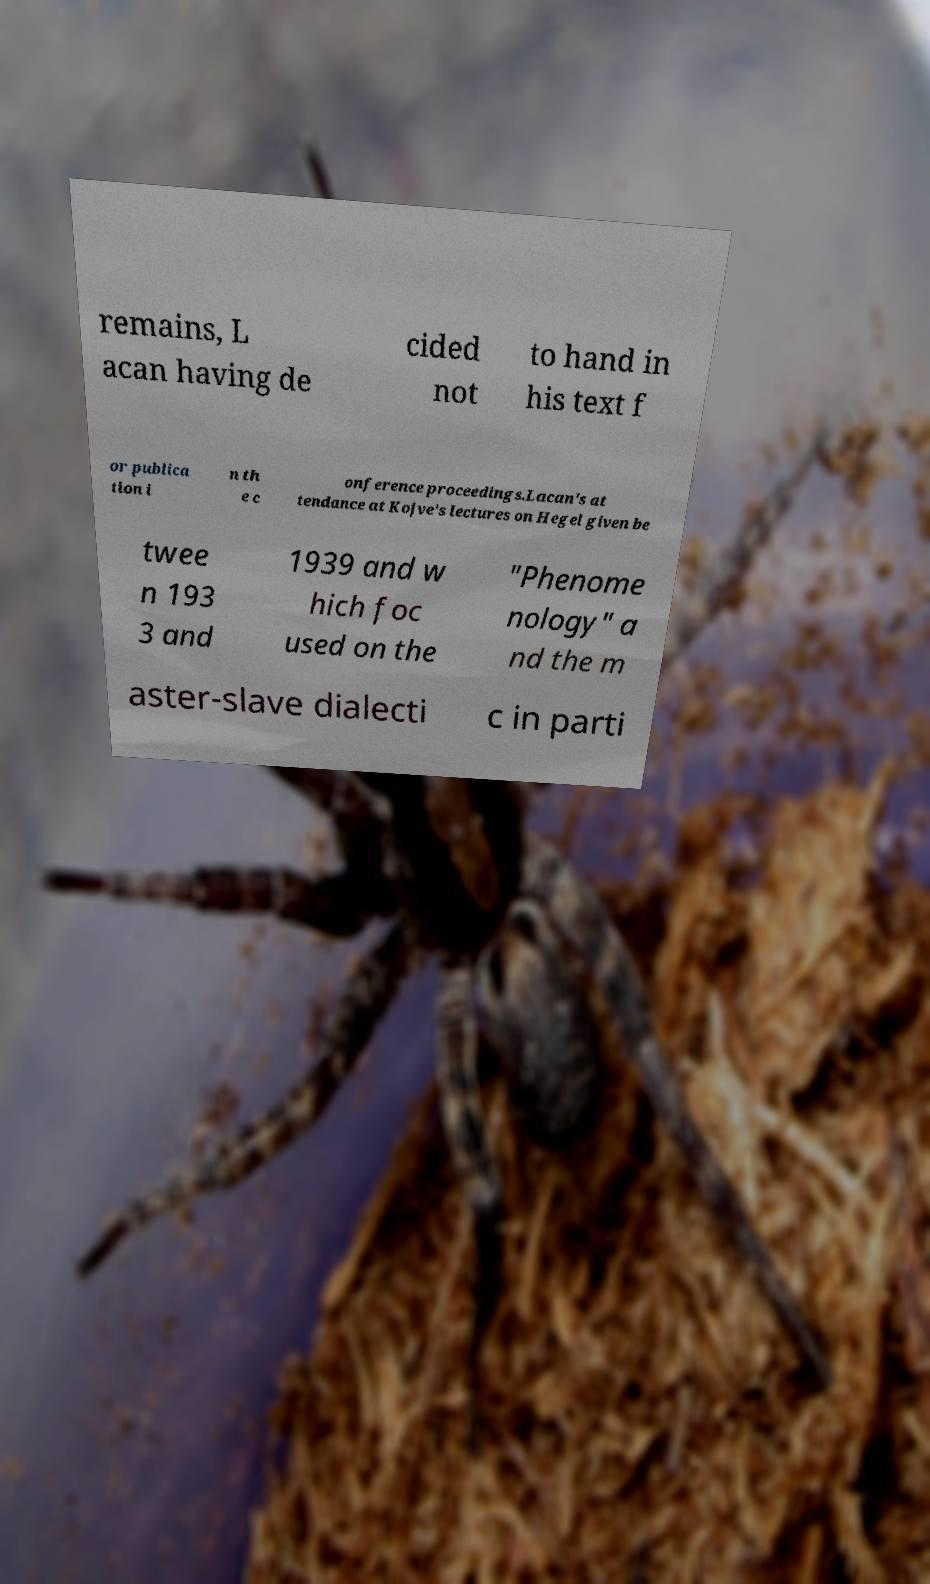Can you accurately transcribe the text from the provided image for me? remains, L acan having de cided not to hand in his text f or publica tion i n th e c onference proceedings.Lacan's at tendance at Kojve's lectures on Hegel given be twee n 193 3 and 1939 and w hich foc used on the "Phenome nology" a nd the m aster-slave dialecti c in parti 